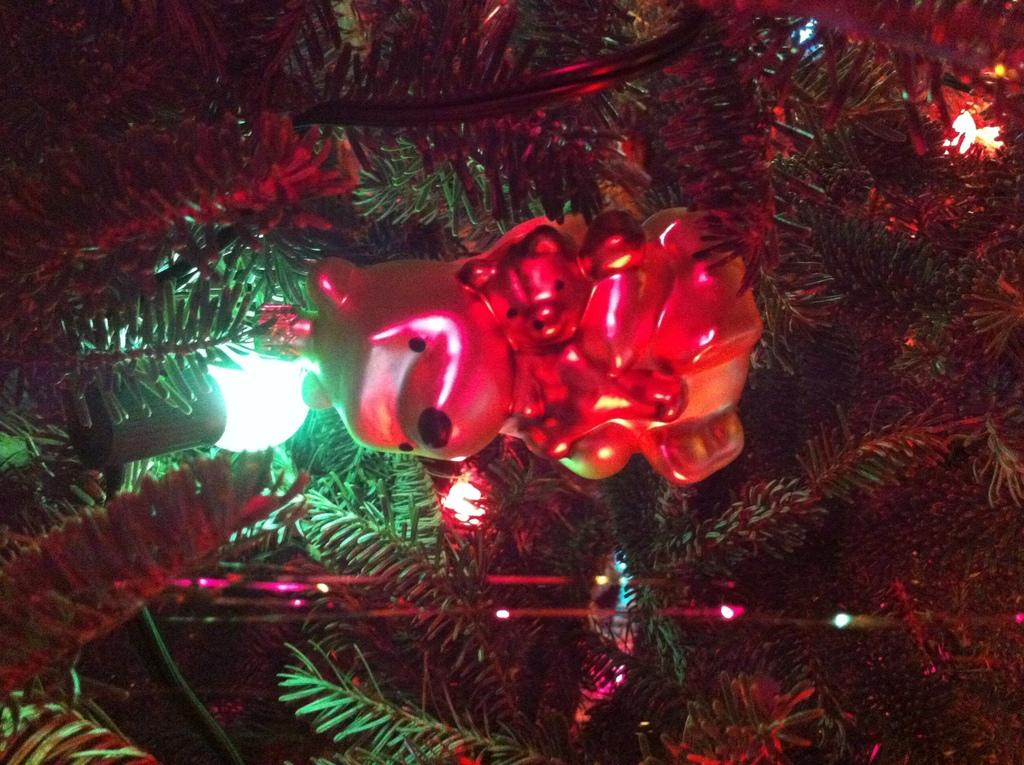What object can be seen in the image? There is a toy in the image. Where is the toy located? The toy is hanging from a Christmas tree. What type of cheese is being offered by the mom in the image? There is no cheese or mom present in the image; it only features a toy hanging from a Christmas tree. 